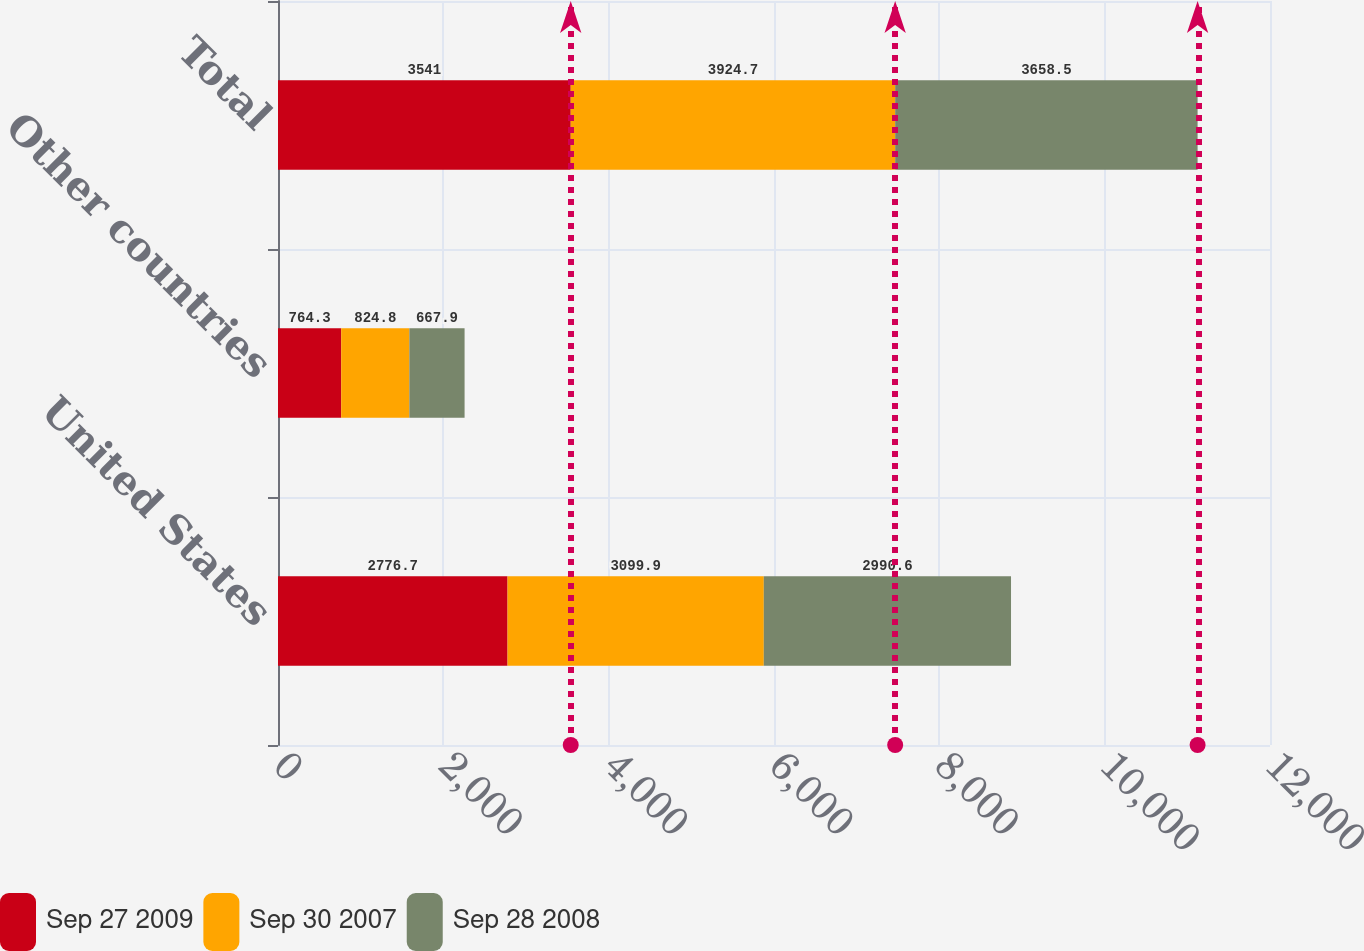<chart> <loc_0><loc_0><loc_500><loc_500><stacked_bar_chart><ecel><fcel>United States<fcel>Other countries<fcel>Total<nl><fcel>Sep 27 2009<fcel>2776.7<fcel>764.3<fcel>3541<nl><fcel>Sep 30 2007<fcel>3099.9<fcel>824.8<fcel>3924.7<nl><fcel>Sep 28 2008<fcel>2990.6<fcel>667.9<fcel>3658.5<nl></chart> 